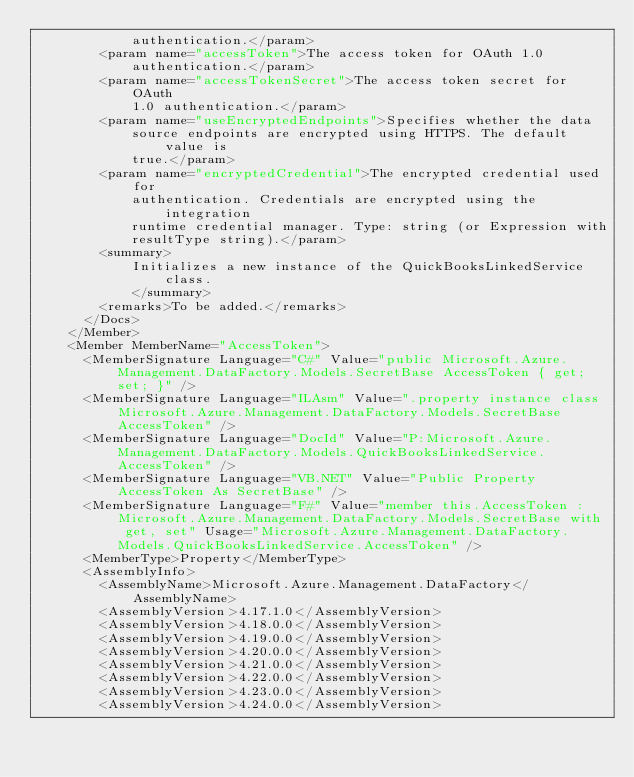<code> <loc_0><loc_0><loc_500><loc_500><_XML_>            authentication.</param>
        <param name="accessToken">The access token for OAuth 1.0
            authentication.</param>
        <param name="accessTokenSecret">The access token secret for OAuth
            1.0 authentication.</param>
        <param name="useEncryptedEndpoints">Specifies whether the data
            source endpoints are encrypted using HTTPS. The default value is
            true.</param>
        <param name="encryptedCredential">The encrypted credential used for
            authentication. Credentials are encrypted using the integration
            runtime credential manager. Type: string (or Expression with
            resultType string).</param>
        <summary>
            Initializes a new instance of the QuickBooksLinkedService class.
            </summary>
        <remarks>To be added.</remarks>
      </Docs>
    </Member>
    <Member MemberName="AccessToken">
      <MemberSignature Language="C#" Value="public Microsoft.Azure.Management.DataFactory.Models.SecretBase AccessToken { get; set; }" />
      <MemberSignature Language="ILAsm" Value=".property instance class Microsoft.Azure.Management.DataFactory.Models.SecretBase AccessToken" />
      <MemberSignature Language="DocId" Value="P:Microsoft.Azure.Management.DataFactory.Models.QuickBooksLinkedService.AccessToken" />
      <MemberSignature Language="VB.NET" Value="Public Property AccessToken As SecretBase" />
      <MemberSignature Language="F#" Value="member this.AccessToken : Microsoft.Azure.Management.DataFactory.Models.SecretBase with get, set" Usage="Microsoft.Azure.Management.DataFactory.Models.QuickBooksLinkedService.AccessToken" />
      <MemberType>Property</MemberType>
      <AssemblyInfo>
        <AssemblyName>Microsoft.Azure.Management.DataFactory</AssemblyName>
        <AssemblyVersion>4.17.1.0</AssemblyVersion>
        <AssemblyVersion>4.18.0.0</AssemblyVersion>
        <AssemblyVersion>4.19.0.0</AssemblyVersion>
        <AssemblyVersion>4.20.0.0</AssemblyVersion>
        <AssemblyVersion>4.21.0.0</AssemblyVersion>
        <AssemblyVersion>4.22.0.0</AssemblyVersion>
        <AssemblyVersion>4.23.0.0</AssemblyVersion>
        <AssemblyVersion>4.24.0.0</AssemblyVersion></code> 